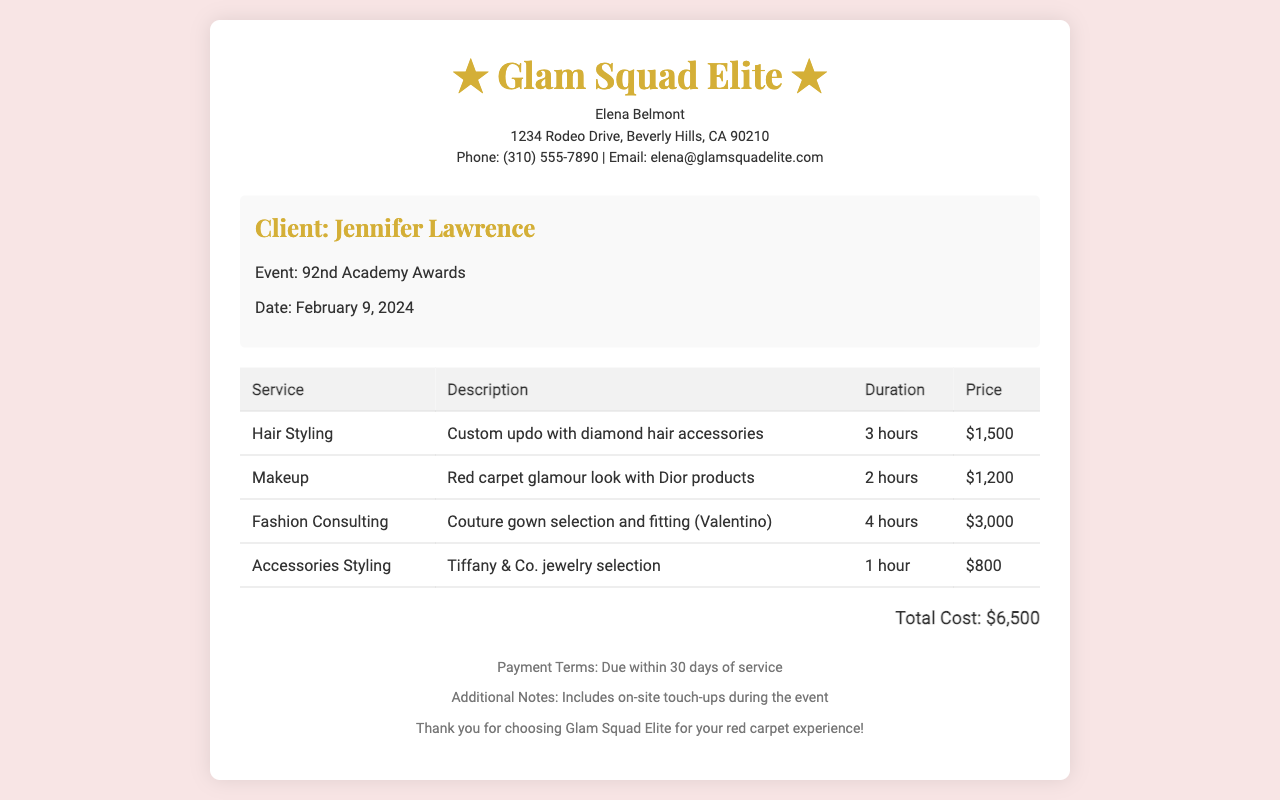What is the name of the client? The client's name, as stated in the document, is Jennifer Lawrence.
Answer: Jennifer Lawrence What is the date of the event? The document specifies the date of the event as February 9, 2024.
Answer: February 9, 2024 How much does the hair styling service cost? The cost for hair styling is listed in the table, which shows it costs $1,500.
Answer: $1,500 What is the total cost of all services? The total cost is mentioned at the end of the document, summing all the services, which is $6,500.
Answer: $6,500 How long is the fashion consulting service? The duration for fashion consulting is detailed in the table, showing it takes 4 hours.
Answer: 4 hours Who is the service provider? The service provider is identified in the header of the document as Glam Squad Elite.
Answer: Glam Squad Elite What type of jewelry is included in the accessories styling? The document specifies that the jewelry comes from Tiffany & Co.
Answer: Tiffany & Co What is included in the additional notes? The additional notes state that on-site touch-ups during the event are included.
Answer: On-site touch-ups What products are used for the makeup service? The makeup service description mentions that Dior products are used.
Answer: Dior products 